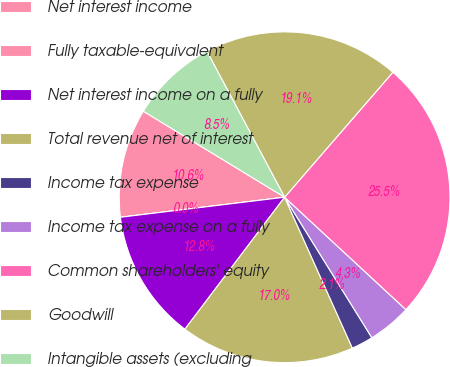Convert chart to OTSL. <chart><loc_0><loc_0><loc_500><loc_500><pie_chart><fcel>Net interest income<fcel>Fully taxable-equivalent<fcel>Net interest income on a fully<fcel>Total revenue net of interest<fcel>Income tax expense<fcel>Income tax expense on a fully<fcel>Common shareholders' equity<fcel>Goodwill<fcel>Intangible assets (excluding<nl><fcel>10.64%<fcel>0.0%<fcel>12.77%<fcel>17.02%<fcel>2.13%<fcel>4.26%<fcel>25.53%<fcel>19.15%<fcel>8.51%<nl></chart> 